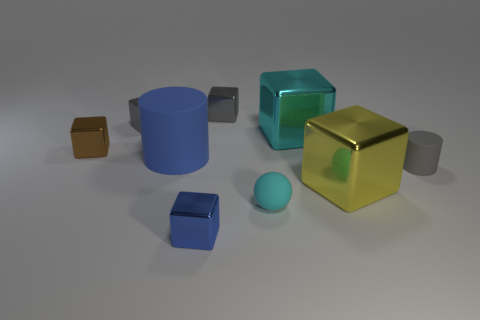Do the large cylinder and the tiny thing that is right of the tiny sphere have the same color?
Your response must be concise. No. What number of objects are either gray things that are in front of the tiny brown object or tiny brown things in front of the cyan metallic object?
Your response must be concise. 2. What is the shape of the small gray object on the left side of the shiny object that is in front of the big yellow thing?
Give a very brief answer. Cube. Is there another small object made of the same material as the tiny cyan thing?
Your response must be concise. Yes. What is the color of the other big thing that is the same shape as the big cyan metal thing?
Make the answer very short. Yellow. Is the number of small gray metal objects in front of the small blue shiny cube less than the number of metal things on the right side of the rubber sphere?
Your answer should be very brief. Yes. What number of other things are there of the same shape as the cyan metallic thing?
Your answer should be very brief. 5. Is the number of cylinders in front of the yellow thing less than the number of small shiny objects?
Give a very brief answer. Yes. There is a tiny cylinder that is behind the big yellow metal object; what is its material?
Give a very brief answer. Rubber. How many other objects are the same size as the brown shiny block?
Your response must be concise. 5. 